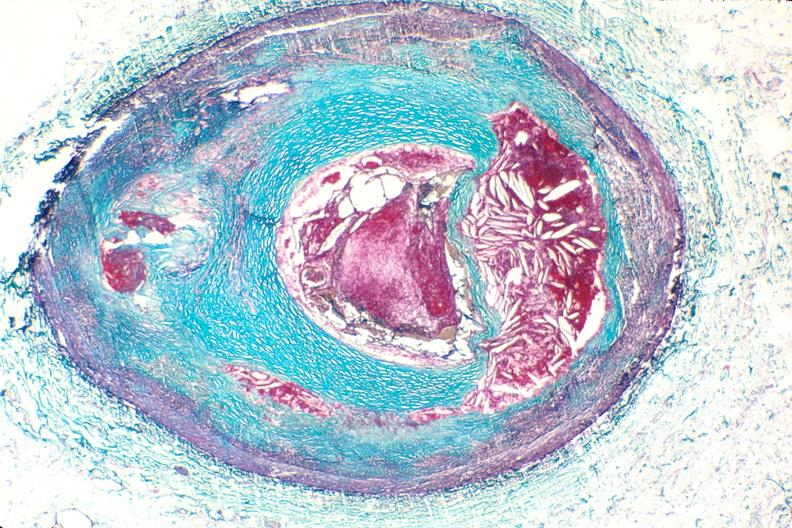s vasculature present?
Answer the question using a single word or phrase. Yes 